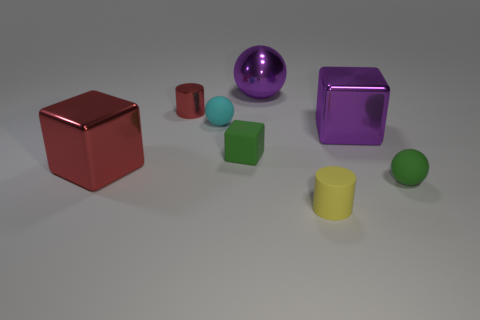Subtract all big cubes. How many cubes are left? 1 Add 2 large purple rubber spheres. How many objects exist? 10 Subtract all cubes. How many objects are left? 5 Add 6 tiny spheres. How many tiny spheres exist? 8 Subtract all red cylinders. How many cylinders are left? 1 Subtract 0 green cylinders. How many objects are left? 8 Subtract 1 balls. How many balls are left? 2 Subtract all brown blocks. Subtract all green cylinders. How many blocks are left? 3 Subtract all red balls. How many cyan cylinders are left? 0 Subtract all rubber cylinders. Subtract all red metallic cylinders. How many objects are left? 6 